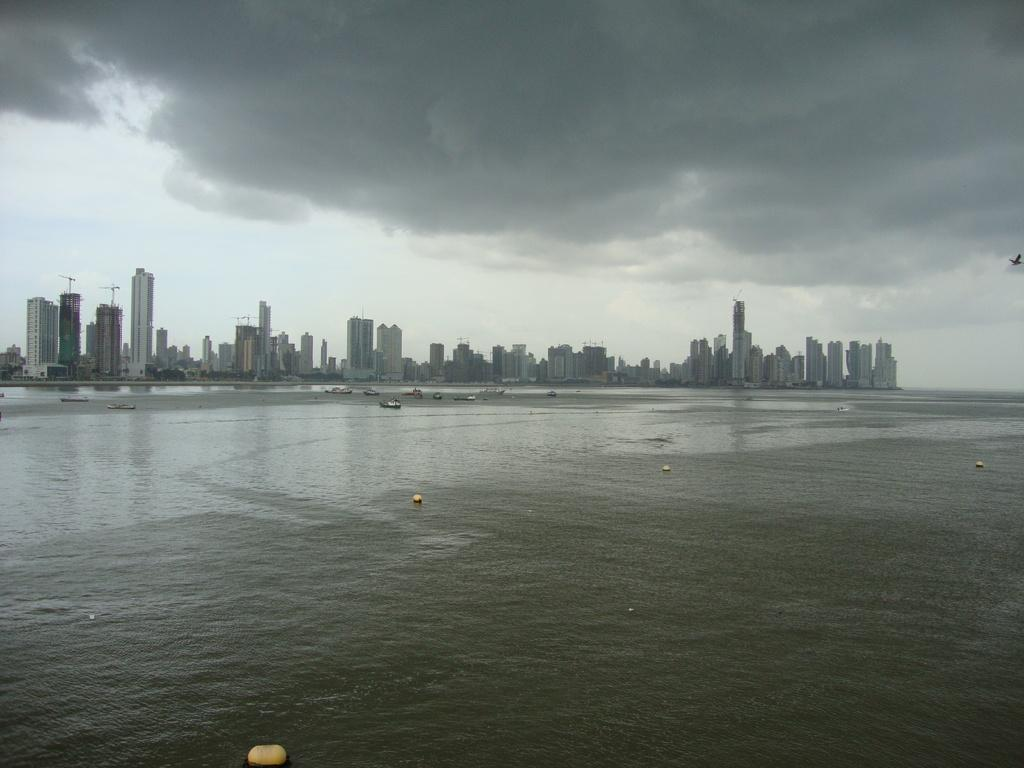What can be seen in the water in the foreground of the image? There are boats in the water in the foreground of the image. What type of structures are visible in the image? There are buildings and towers visible in the image. What is visible at the top of the image? The sky is visible at the top of the image. What might be the location of the image? The image may have been taken near a lake, given the presence of boats in the water. What type of butter is being used to draw on the pen in the image? There is no butter or pen present in the image. How many boats are visible in the image? The number of boats cannot be determined from the provided facts, as it only states that there are boats in the water in the foreground of the image. 